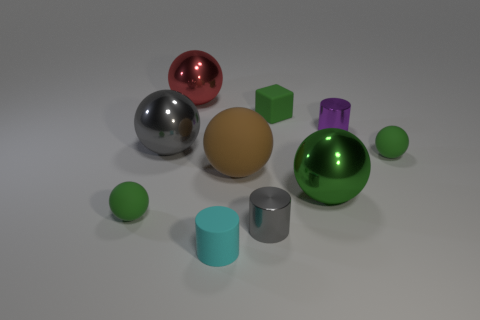Subtract all yellow cylinders. How many green spheres are left? 3 Subtract all big green metal balls. How many balls are left? 5 Subtract all gray spheres. How many spheres are left? 5 Subtract 3 balls. How many balls are left? 3 Subtract all brown spheres. Subtract all yellow cylinders. How many spheres are left? 5 Subtract all cylinders. How many objects are left? 7 Add 4 big gray shiny objects. How many big gray shiny objects are left? 5 Add 4 tiny purple metallic objects. How many tiny purple metallic objects exist? 5 Subtract 0 green cylinders. How many objects are left? 10 Subtract all big red things. Subtract all red metal objects. How many objects are left? 8 